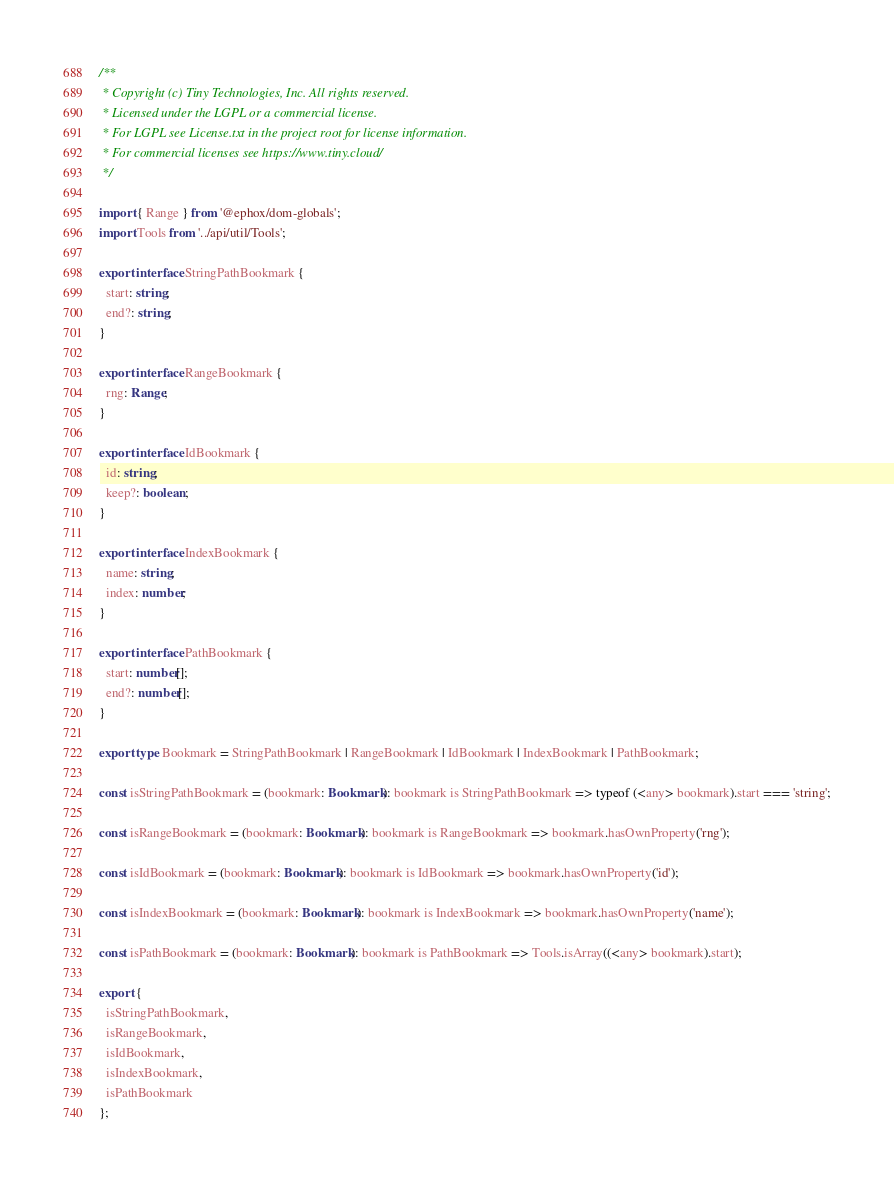Convert code to text. <code><loc_0><loc_0><loc_500><loc_500><_TypeScript_>/**
 * Copyright (c) Tiny Technologies, Inc. All rights reserved.
 * Licensed under the LGPL or a commercial license.
 * For LGPL see License.txt in the project root for license information.
 * For commercial licenses see https://www.tiny.cloud/
 */

import { Range } from '@ephox/dom-globals';
import Tools from '../api/util/Tools';

export interface StringPathBookmark {
  start: string;
  end?: string;
}

export interface RangeBookmark {
  rng: Range;
}

export interface IdBookmark {
  id: string;
  keep?: boolean;
}

export interface IndexBookmark {
  name: string;
  index: number;
}

export interface PathBookmark {
  start: number[];
  end?: number[];
}

export type Bookmark = StringPathBookmark | RangeBookmark | IdBookmark | IndexBookmark | PathBookmark;

const isStringPathBookmark = (bookmark: Bookmark): bookmark is StringPathBookmark => typeof (<any> bookmark).start === 'string';

const isRangeBookmark = (bookmark: Bookmark): bookmark is RangeBookmark => bookmark.hasOwnProperty('rng');

const isIdBookmark = (bookmark: Bookmark): bookmark is IdBookmark => bookmark.hasOwnProperty('id');

const isIndexBookmark = (bookmark: Bookmark): bookmark is IndexBookmark => bookmark.hasOwnProperty('name');

const isPathBookmark = (bookmark: Bookmark): bookmark is PathBookmark => Tools.isArray((<any> bookmark).start);

export {
  isStringPathBookmark,
  isRangeBookmark,
  isIdBookmark,
  isIndexBookmark,
  isPathBookmark
};
</code> 